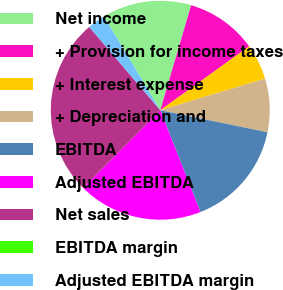<chart> <loc_0><loc_0><loc_500><loc_500><pie_chart><fcel>Net income<fcel>+ Provision for income taxes<fcel>+ Interest expense<fcel>+ Depreciation and<fcel>EBITDA<fcel>Adjusted EBITDA<fcel>Net sales<fcel>EBITDA margin<fcel>Adjusted EBITDA margin<nl><fcel>13.16%<fcel>10.53%<fcel>5.26%<fcel>7.89%<fcel>15.79%<fcel>18.42%<fcel>26.32%<fcel>0.0%<fcel>2.63%<nl></chart> 